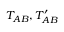<formula> <loc_0><loc_0><loc_500><loc_500>T _ { A B } , T _ { A B } ^ { \prime }</formula> 